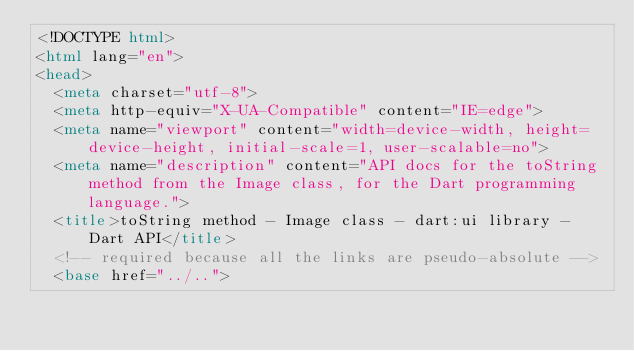<code> <loc_0><loc_0><loc_500><loc_500><_HTML_><!DOCTYPE html>
<html lang="en">
<head>
  <meta charset="utf-8">
  <meta http-equiv="X-UA-Compatible" content="IE=edge">
  <meta name="viewport" content="width=device-width, height=device-height, initial-scale=1, user-scalable=no">
  <meta name="description" content="API docs for the toString method from the Image class, for the Dart programming language.">
  <title>toString method - Image class - dart:ui library - Dart API</title>
  <!-- required because all the links are pseudo-absolute -->
  <base href="../..">
</code> 